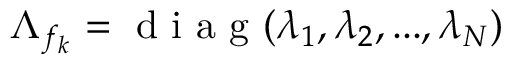Convert formula to latex. <formula><loc_0><loc_0><loc_500><loc_500>\Lambda _ { f _ { k } } = d i a g ( \lambda _ { 1 } , \lambda _ { 2 } , \dots , \lambda _ { N } )</formula> 